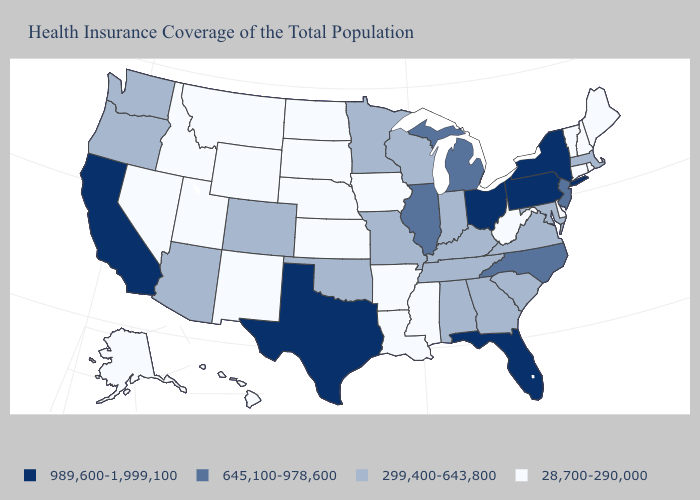Name the states that have a value in the range 28,700-290,000?
Be succinct. Alaska, Arkansas, Connecticut, Delaware, Hawaii, Idaho, Iowa, Kansas, Louisiana, Maine, Mississippi, Montana, Nebraska, Nevada, New Hampshire, New Mexico, North Dakota, Rhode Island, South Dakota, Utah, Vermont, West Virginia, Wyoming. Which states hav the highest value in the Northeast?
Short answer required. New York, Pennsylvania. Name the states that have a value in the range 299,400-643,800?
Be succinct. Alabama, Arizona, Colorado, Georgia, Indiana, Kentucky, Maryland, Massachusetts, Minnesota, Missouri, Oklahoma, Oregon, South Carolina, Tennessee, Virginia, Washington, Wisconsin. How many symbols are there in the legend?
Give a very brief answer. 4. What is the value of New Mexico?
Write a very short answer. 28,700-290,000. What is the highest value in the West ?
Concise answer only. 989,600-1,999,100. What is the value of Mississippi?
Keep it brief. 28,700-290,000. Does Missouri have a higher value than Nebraska?
Keep it brief. Yes. Does Wisconsin have the highest value in the USA?
Answer briefly. No. What is the value of New Mexico?
Be succinct. 28,700-290,000. Does Florida have the same value as New Hampshire?
Write a very short answer. No. What is the value of Kansas?
Be succinct. 28,700-290,000. What is the highest value in the USA?
Keep it brief. 989,600-1,999,100. Name the states that have a value in the range 28,700-290,000?
Write a very short answer. Alaska, Arkansas, Connecticut, Delaware, Hawaii, Idaho, Iowa, Kansas, Louisiana, Maine, Mississippi, Montana, Nebraska, Nevada, New Hampshire, New Mexico, North Dakota, Rhode Island, South Dakota, Utah, Vermont, West Virginia, Wyoming. What is the highest value in the South ?
Be succinct. 989,600-1,999,100. 